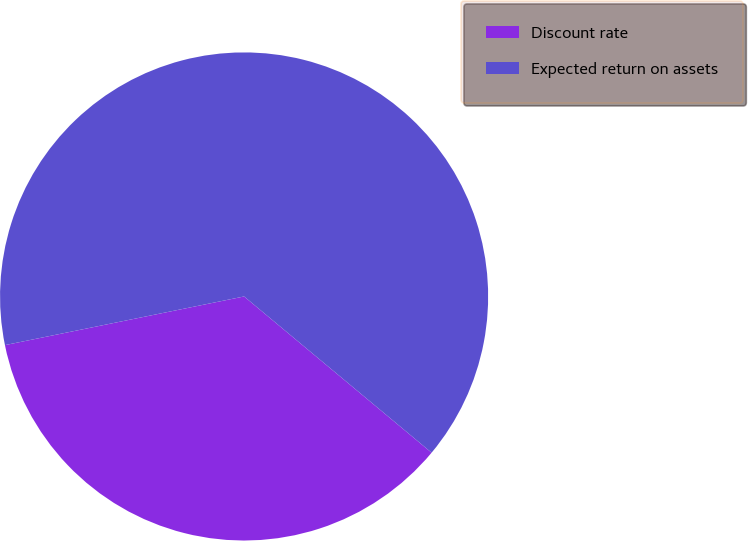Convert chart. <chart><loc_0><loc_0><loc_500><loc_500><pie_chart><fcel>Discount rate<fcel>Expected return on assets<nl><fcel>35.75%<fcel>64.25%<nl></chart> 